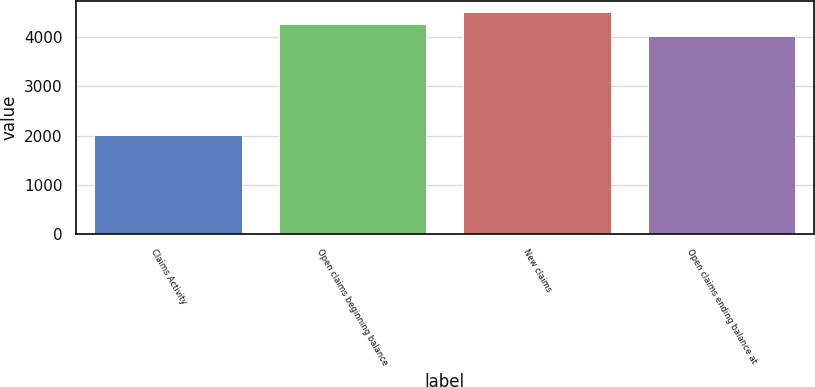<chart> <loc_0><loc_0><loc_500><loc_500><bar_chart><fcel>Claims Activity<fcel>Open claims beginning balance<fcel>New claims<fcel>Open claims ending balance at<nl><fcel>2004<fcel>4264.2<fcel>4500.4<fcel>4028<nl></chart> 